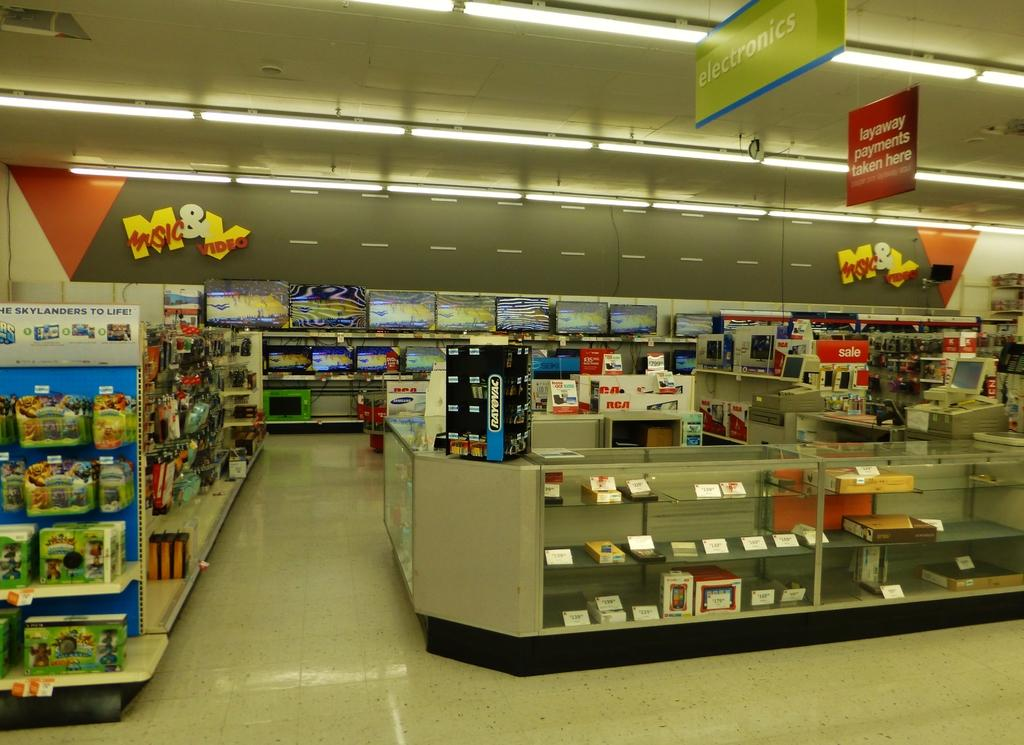What type of objects can be seen in the display cabins and racks in the image? There are objects in display cabins and racks in the image. What type of animals can be seen in the image? There are birds visible in the image. What type of electronic devices can be seen in the image? There are televisions in the image. What type of lighting is present in the image? There are tube lights in the image. Can you describe any other objects present in the image? There are other objects present in the image. What type of music can be heard coming from the cemetery in the image? There is no cemetery present in the image, so it's not possible to determine what, if any, music might be heard. 